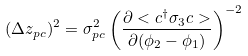Convert formula to latex. <formula><loc_0><loc_0><loc_500><loc_500>( \Delta z _ { p c } ) ^ { 2 } = \sigma _ { p c } ^ { 2 } \left ( \frac { \partial < c ^ { \dag } \sigma _ { 3 } c > } { \partial ( \phi _ { 2 } - \phi _ { 1 } ) } \right ) ^ { - 2 }</formula> 